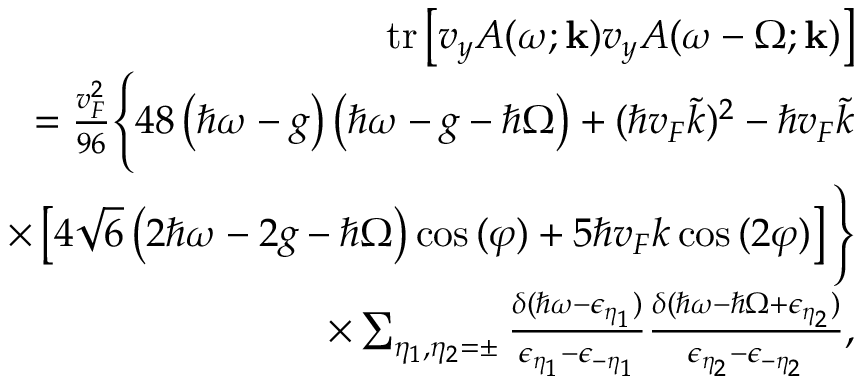<formula> <loc_0><loc_0><loc_500><loc_500>\begin{array} { r l r } & { t r \left [ v _ { y } A ( \omega ; k ) v _ { y } A ( \omega - \Omega ; k ) \right ] } \\ & { = \frac { v _ { F } ^ { 2 } } { 9 6 } \left \{ 4 8 \left ( \hbar { \omega } - g \right ) \left ( \hbar { \omega } - g - \hbar { \Omega } \right ) + ( \hbar { v } _ { F } \tilde { k } ) ^ { 2 } - \hbar { v } _ { F } \tilde { k } } \\ & { \times \left [ 4 \sqrt { 6 } \left ( 2 \hbar { \omega } - 2 g - \hbar { \Omega } \right ) \cos { ( \varphi ) } + 5 \hbar { v } _ { F } k \cos { ( 2 \varphi ) } \right ] \right \} } \\ & { \times \sum _ { \eta _ { 1 } , \eta _ { 2 } = \pm } \frac { \delta ( \hbar { \omega } - \epsilon _ { \eta _ { 1 } } ) } { \epsilon _ { \eta _ { 1 } } - \epsilon _ { - \eta _ { 1 } } } \frac { \delta ( \hbar { \omega } - \hbar { \Omega } + \epsilon _ { \eta _ { 2 } } ) } { \epsilon _ { \eta _ { 2 } } - \epsilon _ { - \eta _ { 2 } } } , } \end{array}</formula> 